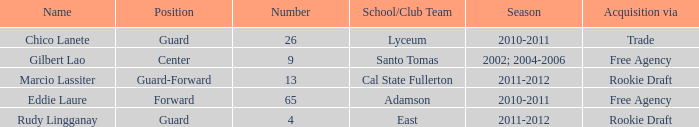Which number corresponds to a player acquired through the rookie draft and is a member of a school/club team at cal state fullerton? 13.0. 